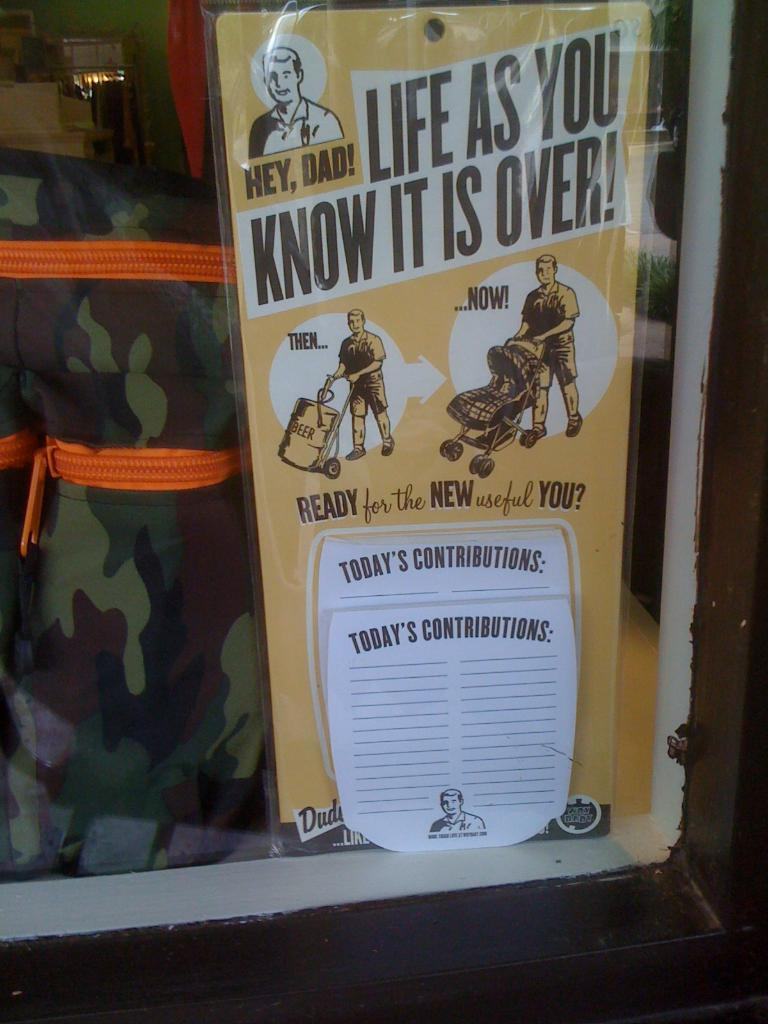<image>
Share a concise interpretation of the image provided. A flyer that says Life As You Know It Is Over. 